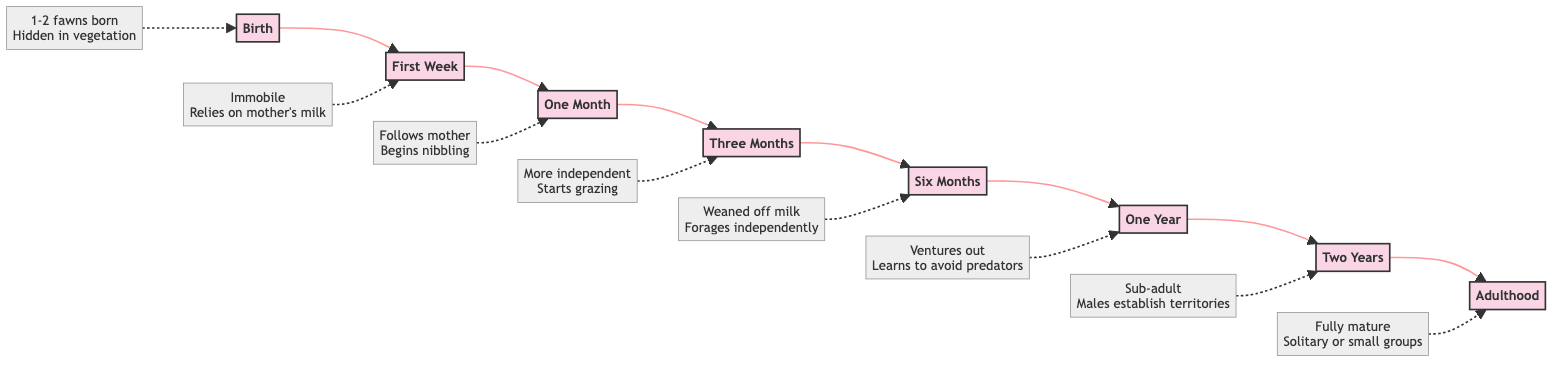What is the first stage of the chinkara's lifecycle? The diagram indicates that the first stage is "Birth." This is the initial node in the flowchart leading to subsequent stages.
Answer: Birth How many fawns does a female chinkara usually give birth to? Referring to the description associated with the "Birth" stage, it states that a female chinkara gives birth to 1-2 fawns. This information is provided in the diagram.
Answer: 1-2 fawns What stage comes after "One Year"? The flowchart indicates that the next stage following "One Year" is "Two Years." The arrows in the diagram clearly show the progression from one stage to the next.
Answer: Two Years At what age is a chinkara considered a sub-adult? According to the "Two Years" stage in the diagram, it is noted that by this age, the chinkara is considered a sub-adult. This information is directly stated in the description of that stage.
Answer: Two Years What does a juvenile chinkara primarily rely on in its first week? The "First Week" stage indicates that the fawn relies entirely on the mother's milk for nutrition during this time. This critical detail is mentioned in the description associated with that stage.
Answer: Mother's milk What significant behavior change occurs at the "One Month" stage? The "One Month" stage describes that the fawn begins to follow the mother around and starts nibbling on grass and leaves. This behavior change signifies its growing independence while still relying on milk.
Answer: Starts nibbling on grass and leaves How many stages are indicated in the lifecycle of a chinkara in the diagram? By counting the individual stages outlined in the flowchart, we see that there are a total of 8 distinct stages from "Birth" to "Adulthood." Each stage is marked in the diagram.
Answer: 8 What is the adult chinkara's social behavior? The "Adulthood" stage description highlights that adult chinkaras are solitary or live in small groups, emphasizing their social behavior characteristics. This information is directly stated in that stage.
Answer: Solitary or small groups 